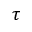Convert formula to latex. <formula><loc_0><loc_0><loc_500><loc_500>\tau</formula> 